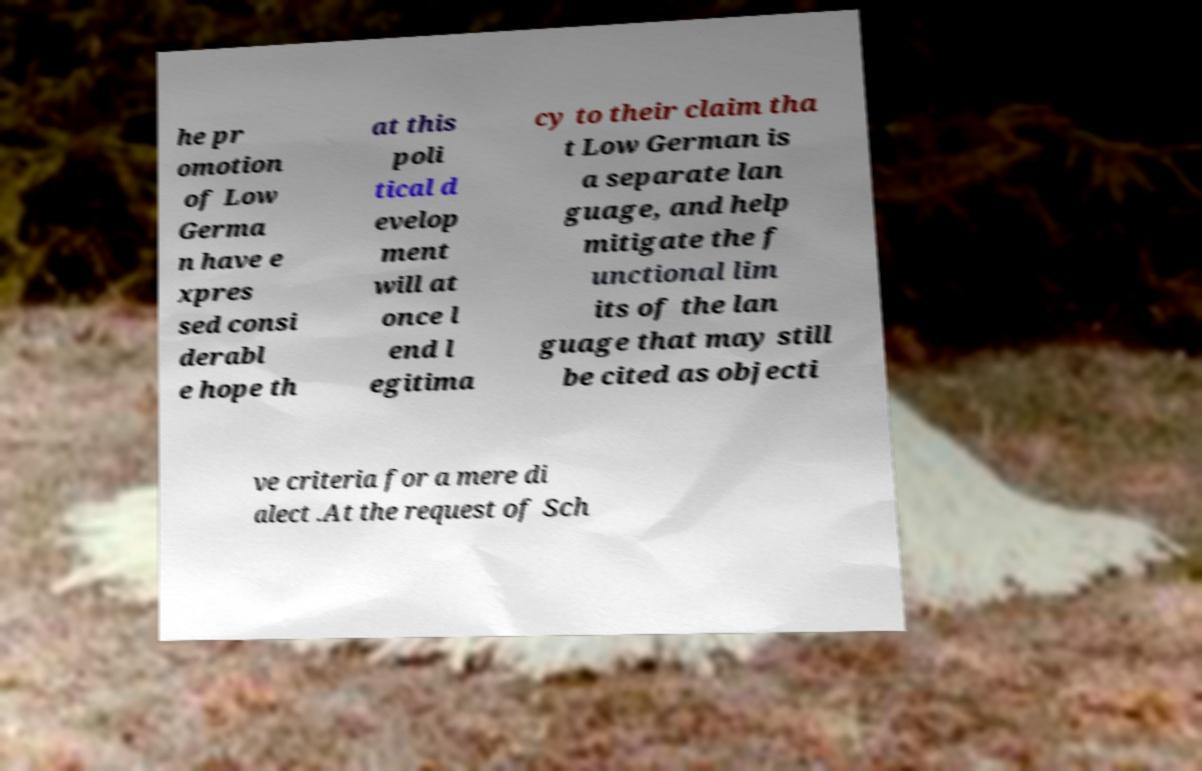What messages or text are displayed in this image? I need them in a readable, typed format. he pr omotion of Low Germa n have e xpres sed consi derabl e hope th at this poli tical d evelop ment will at once l end l egitima cy to their claim tha t Low German is a separate lan guage, and help mitigate the f unctional lim its of the lan guage that may still be cited as objecti ve criteria for a mere di alect .At the request of Sch 